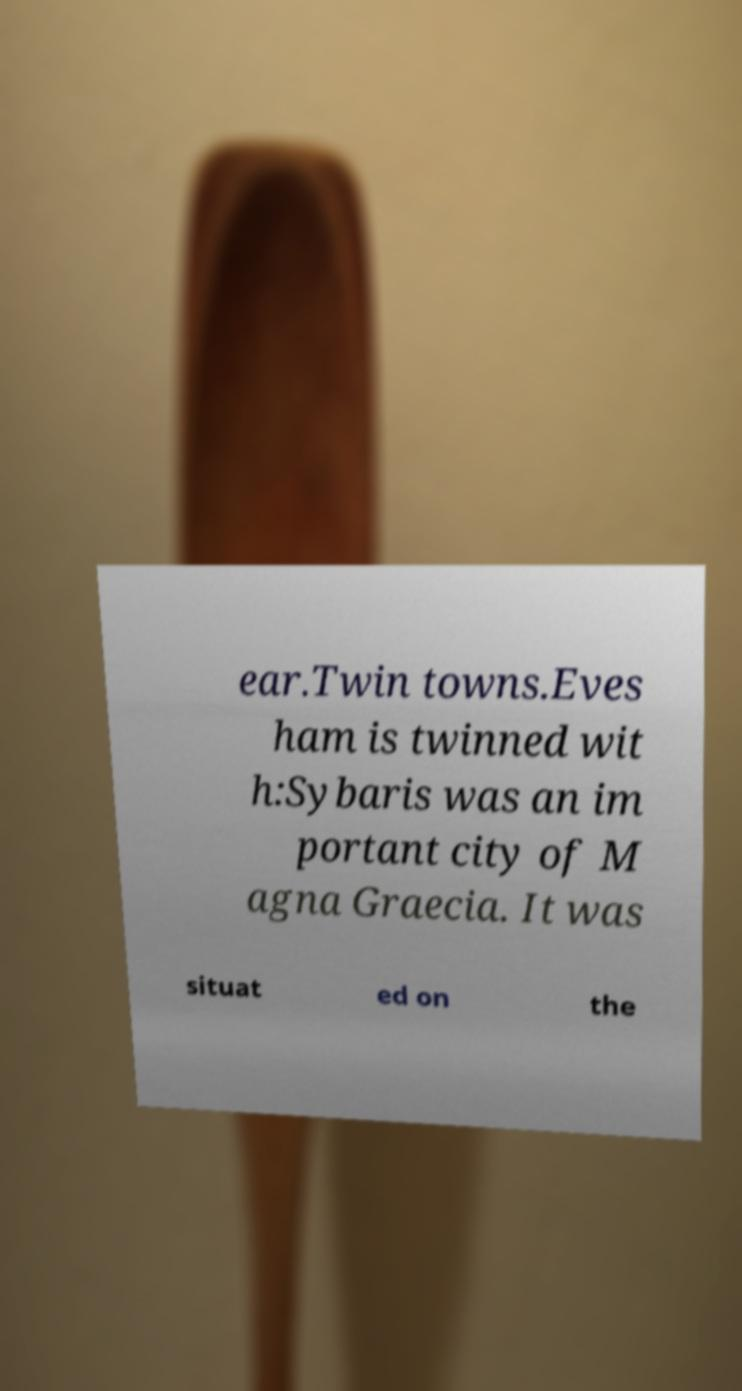There's text embedded in this image that I need extracted. Can you transcribe it verbatim? ear.Twin towns.Eves ham is twinned wit h:Sybaris was an im portant city of M agna Graecia. It was situat ed on the 